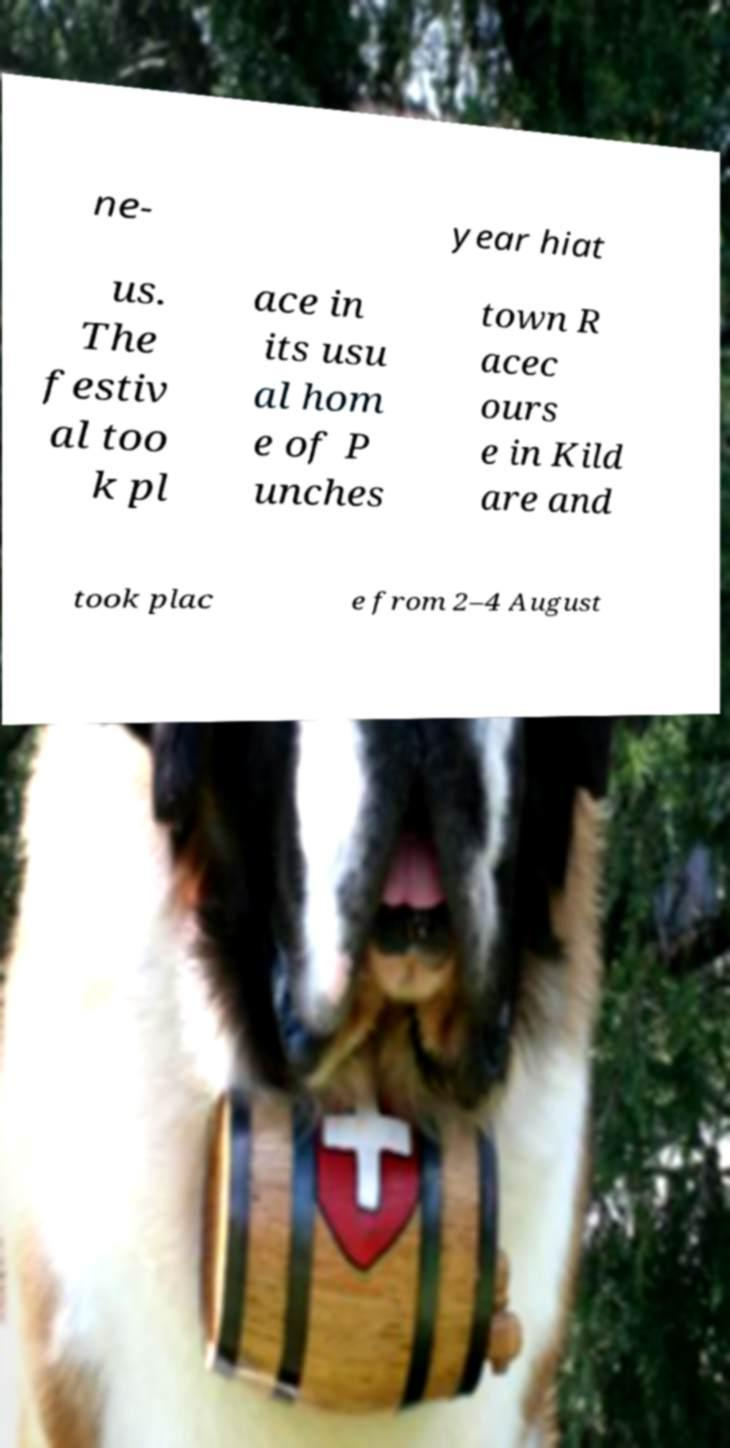For documentation purposes, I need the text within this image transcribed. Could you provide that? ne- year hiat us. The festiv al too k pl ace in its usu al hom e of P unches town R acec ours e in Kild are and took plac e from 2–4 August 